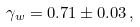<formula> <loc_0><loc_0><loc_500><loc_500>\gamma _ { w } = 0 . 7 1 \pm 0 . 0 3 \, ,</formula> 